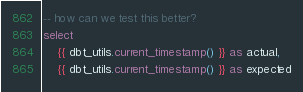<code> <loc_0><loc_0><loc_500><loc_500><_SQL_>
-- how can we test this better?
select
    {{ dbt_utils.current_timestamp() }} as actual,
    {{ dbt_utils.current_timestamp() }} as expected
</code> 